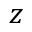Convert formula to latex. <formula><loc_0><loc_0><loc_500><loc_500>z</formula> 